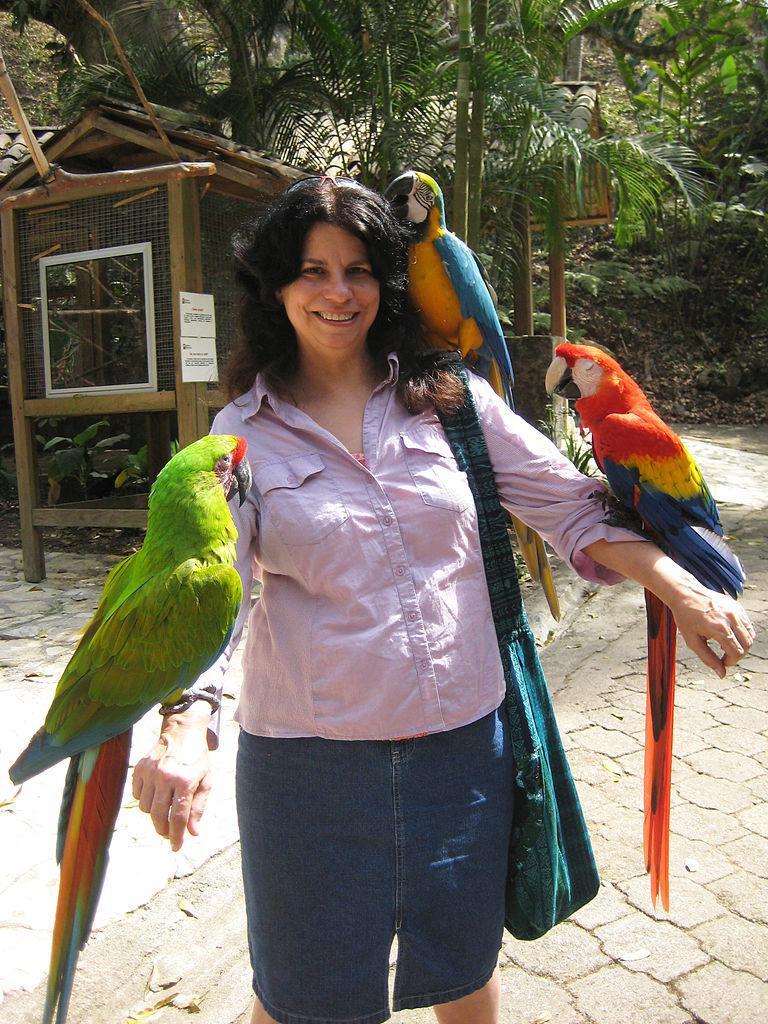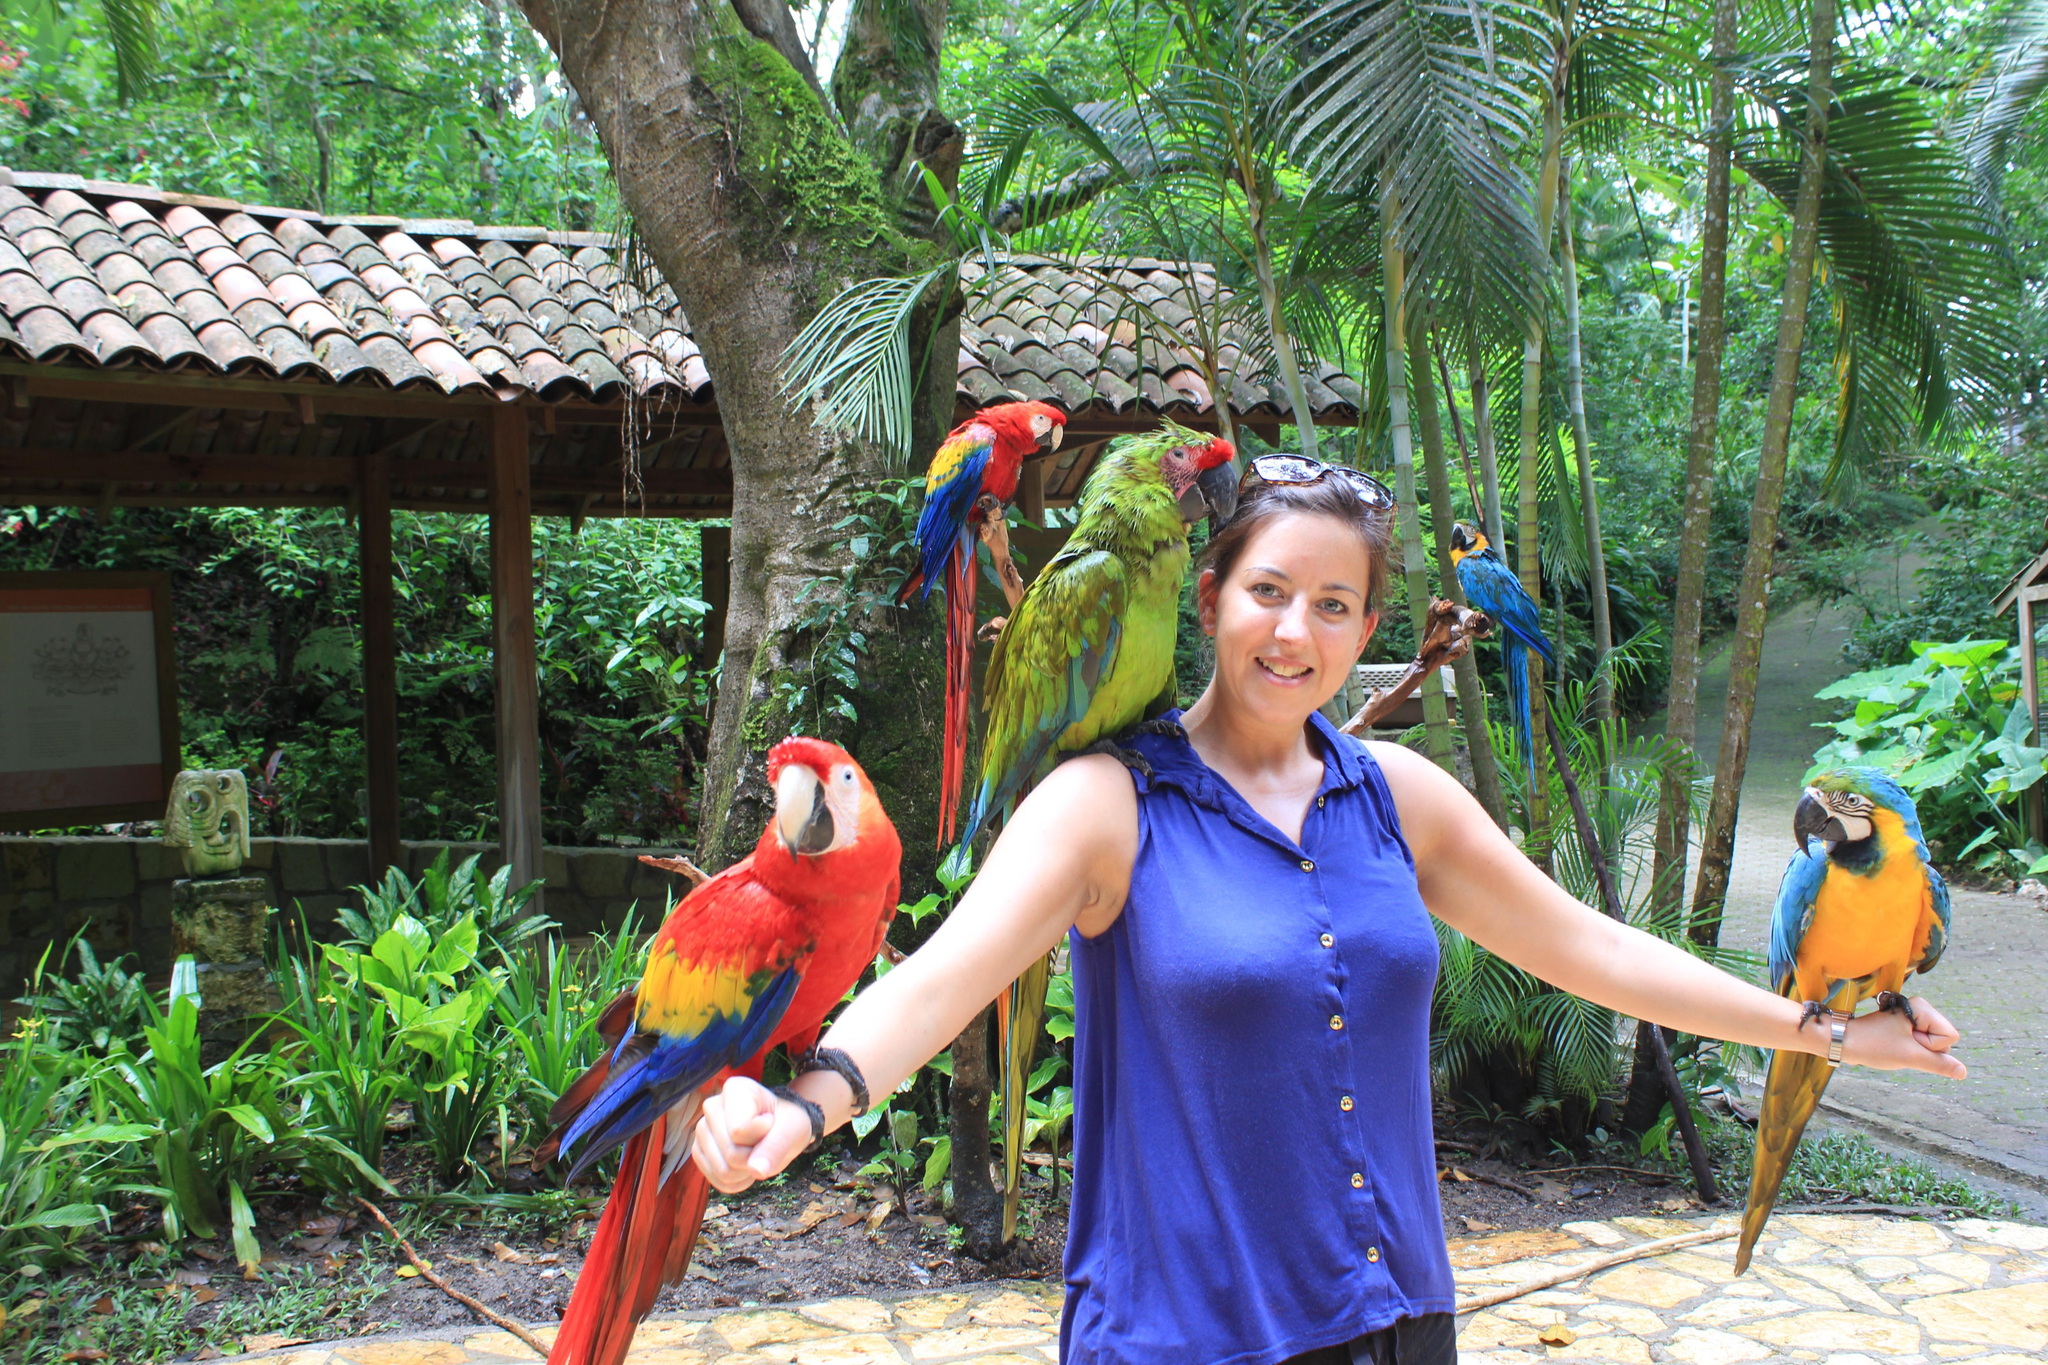The first image is the image on the left, the second image is the image on the right. Assess this claim about the two images: "The combined images show two people with parrots perched on various parts of their bodies.". Correct or not? Answer yes or no. Yes. The first image is the image on the left, the second image is the image on the right. For the images displayed, is the sentence "An image contains various parrots perched on a humans arms and shoulders." factually correct? Answer yes or no. Yes. 